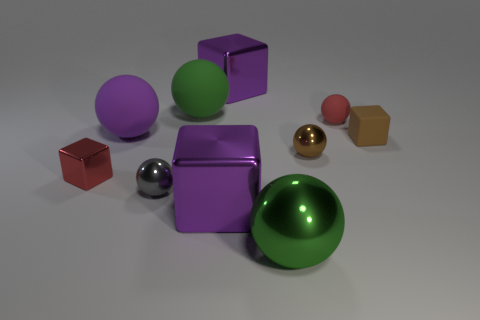How many gray things are made of the same material as the red sphere?
Give a very brief answer. 0. What color is the tiny block that is in front of the tiny block that is behind the tiny red block?
Your answer should be compact. Red. What number of things are either tiny brown metal things or things behind the brown metallic thing?
Your response must be concise. 6. Is there a tiny shiny cylinder that has the same color as the tiny matte sphere?
Offer a terse response. No. How many cyan objects are small shiny blocks or tiny balls?
Your answer should be very brief. 0. What number of other things are the same size as the red sphere?
Your response must be concise. 4. How many big objects are gray metal balls or red blocks?
Provide a succinct answer. 0. There is a red shiny thing; is it the same size as the red thing on the right side of the green metal object?
Your answer should be compact. Yes. How many other things are the same shape as the purple matte thing?
Provide a succinct answer. 5. What is the shape of the tiny thing that is the same material as the tiny brown cube?
Your answer should be compact. Sphere. 